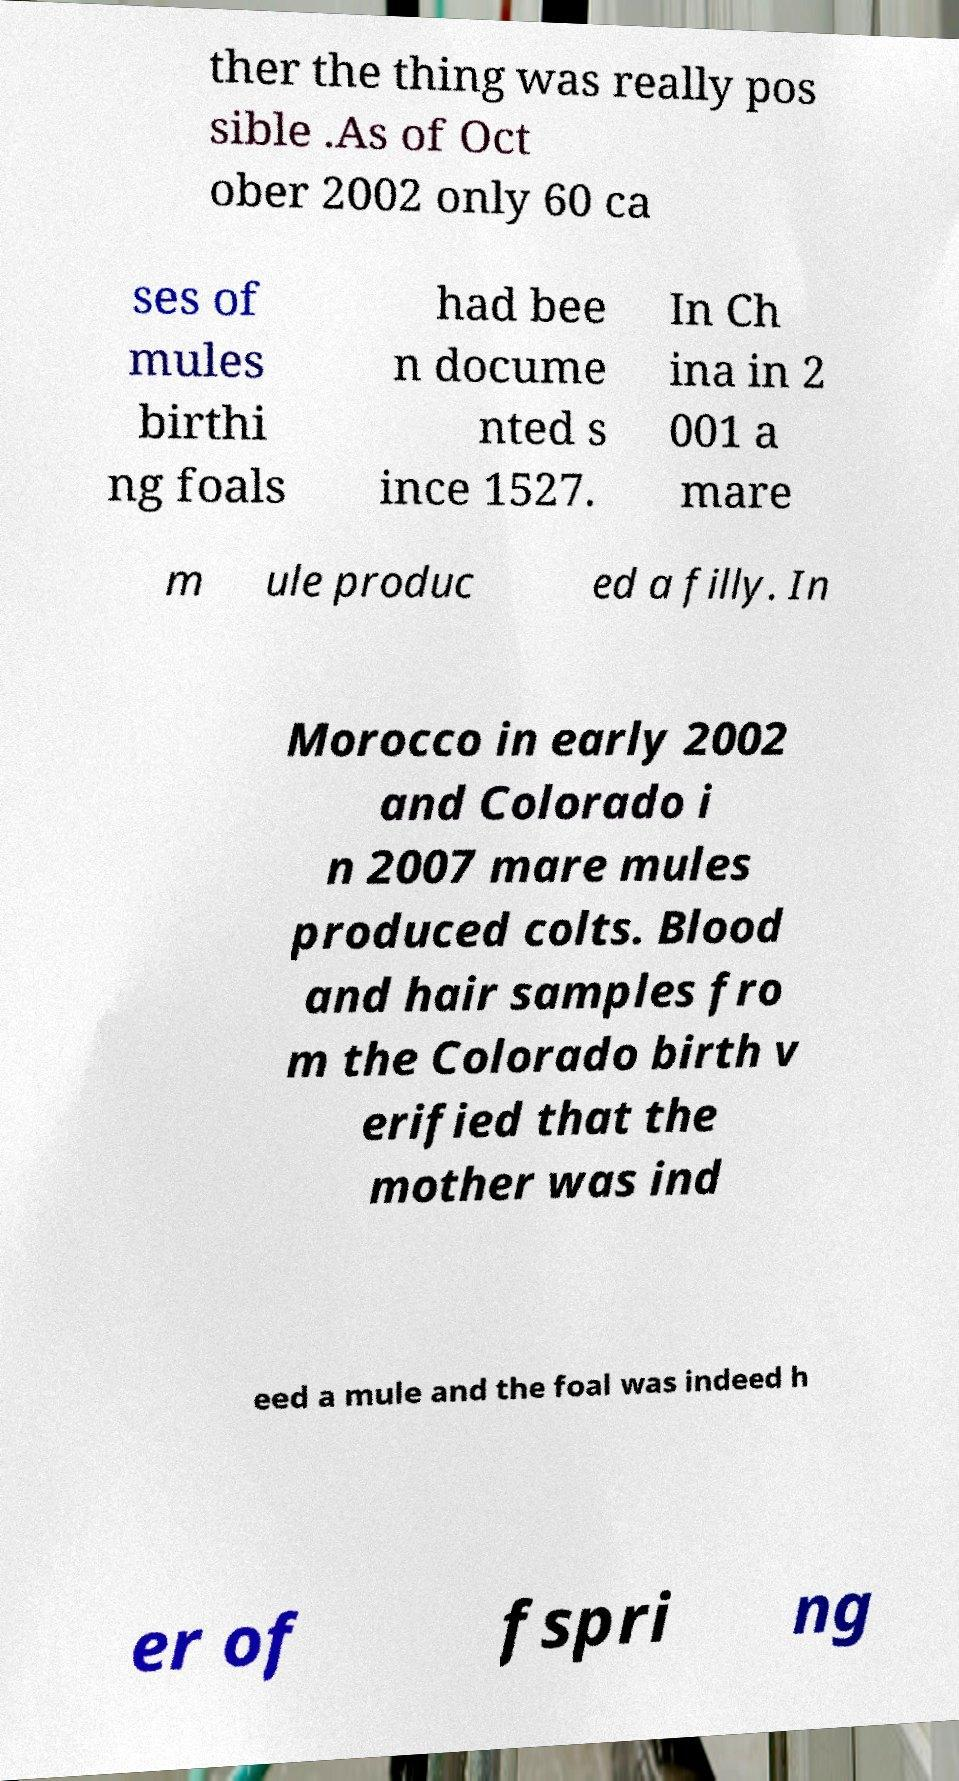Could you assist in decoding the text presented in this image and type it out clearly? ther the thing was really pos sible .As of Oct ober 2002 only 60 ca ses of mules birthi ng foals had bee n docume nted s ince 1527. In Ch ina in 2 001 a mare m ule produc ed a filly. In Morocco in early 2002 and Colorado i n 2007 mare mules produced colts. Blood and hair samples fro m the Colorado birth v erified that the mother was ind eed a mule and the foal was indeed h er of fspri ng 